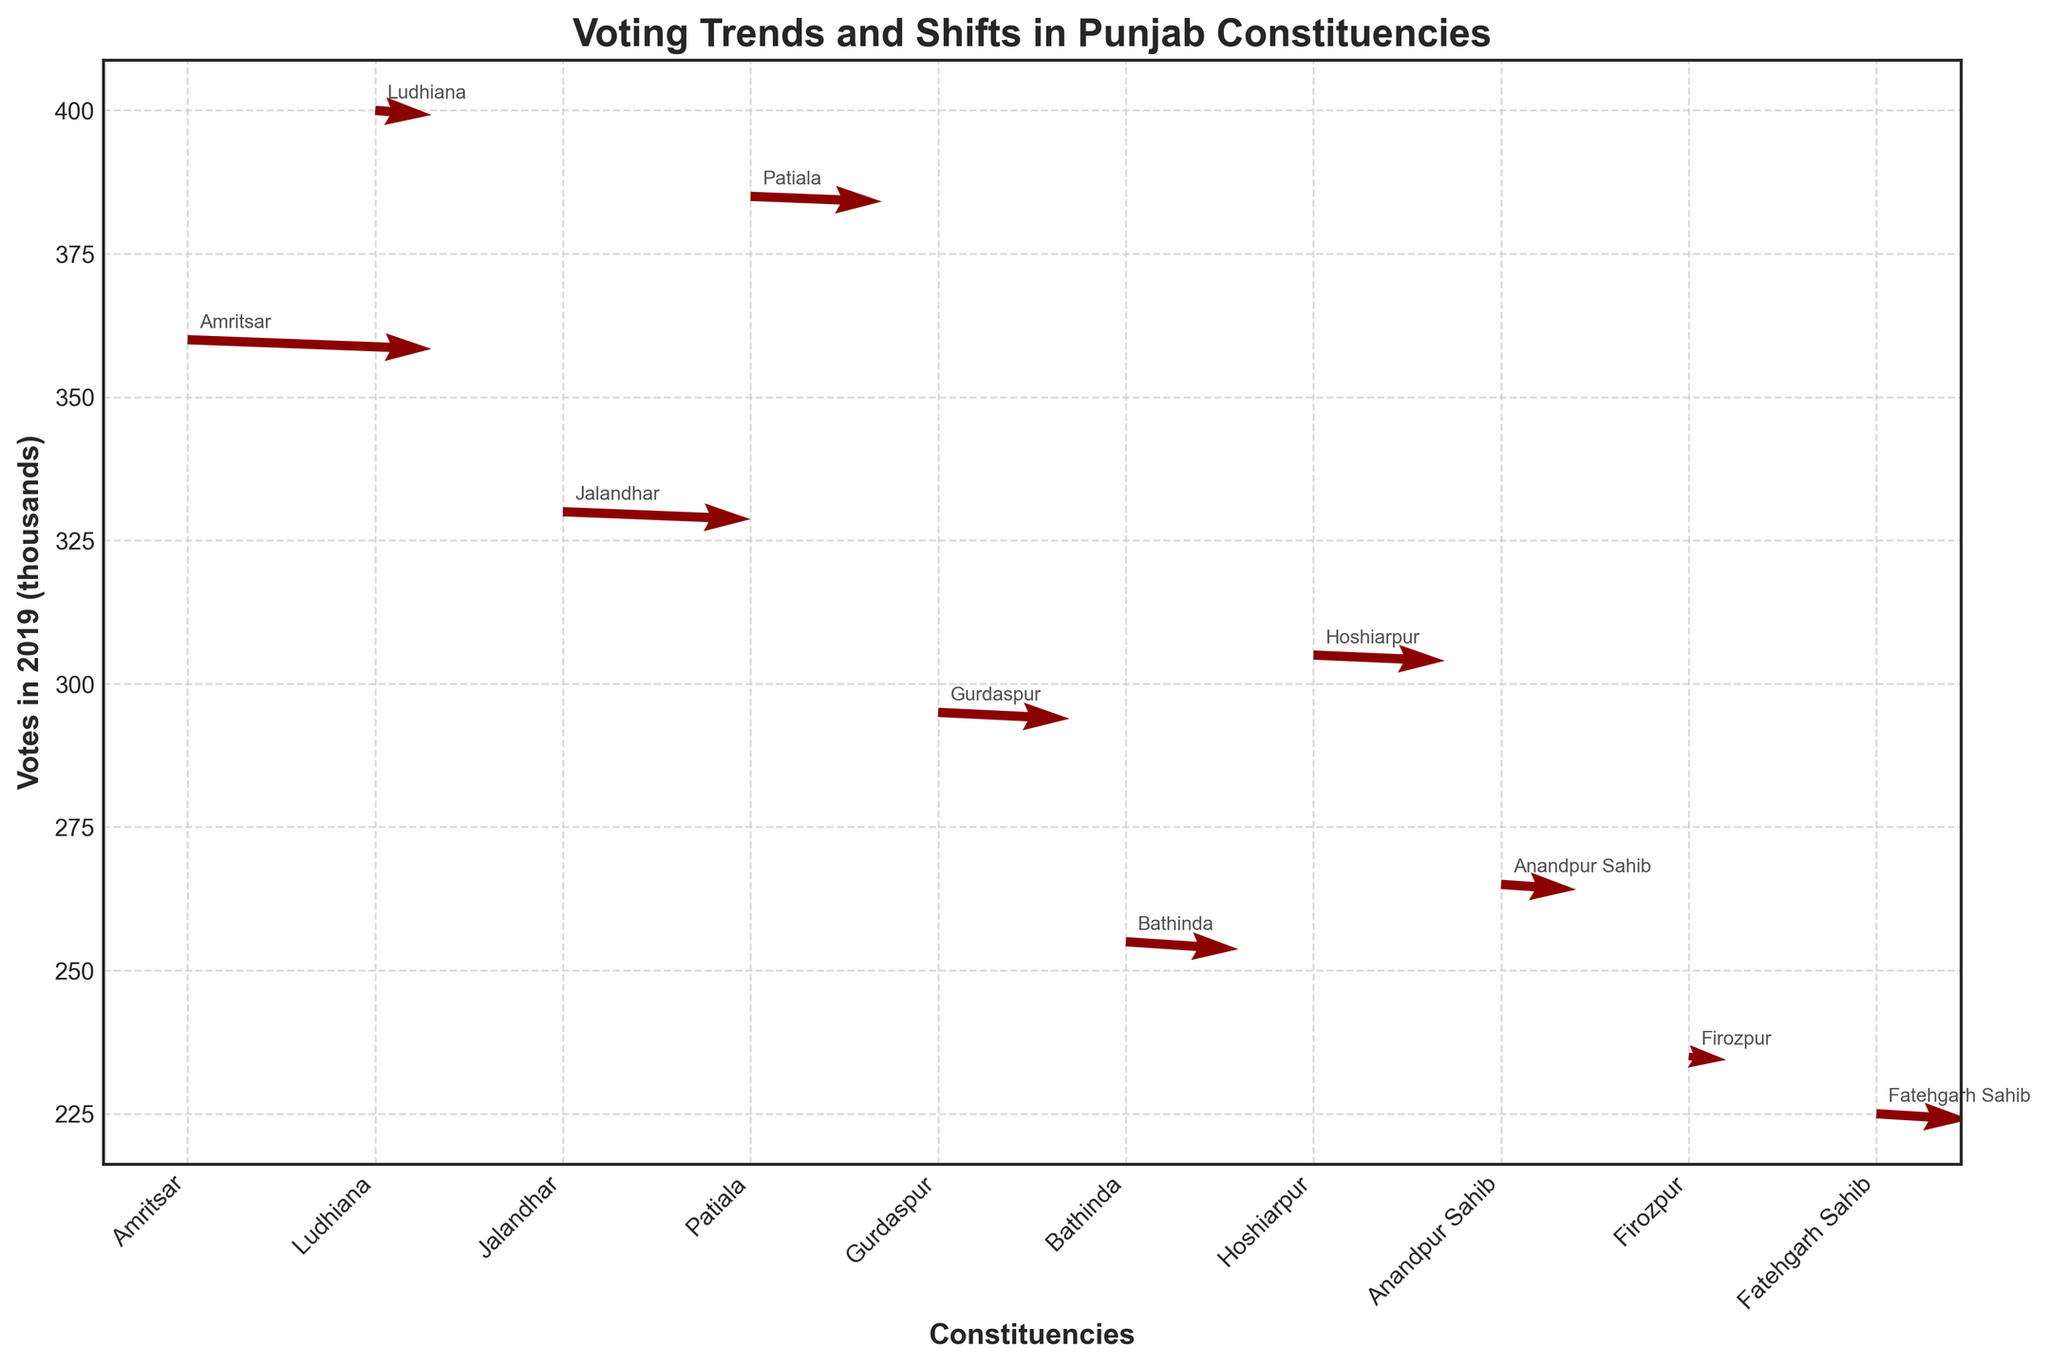What's the title of the plot? The title of the plot is displayed prominently at the top of the figure.
Answer: Voting Trends and Shifts in Punjab Constituencies How many constituencies are represented in the plot? The number of distinct constituency labels on the x-axis represents the number of constituencies. Count these labels to get the answer.
Answer: 10 What is the direction of the voting shift in Amritsar for 2019 compared to 2014? Examine the quiver arrow starting at the point labeled "Amritsar." The U and V components of the vector indicate the direction. For Amritsar, the arrow points generally upward and to the right.
Answer: Upward and to the right Which constituency has the highest number of votes in 2019? Compare the vertical positions of the data points. The highest point on the y-axis corresponds to the constituency with the highest votes in 2019.
Answer: Ludhiana What is the shift in votes for Jalandhar between 2014 and 2019? Locate the arrow corresponding to Jalandhar. The U component (horizontal direction) indicates the vote shift between 2014 and 2019.
Answer: Positive Which constituency showed the largest decrease in votes between 2009 and 2014? Analyze the entire quiver plot. Identify the arrows that point downward and to the left the most, indicating the largest decrease between 2009 and 2014.
Answer: Amritsar What is the average number of votes in 2019 for the constituencies shown? Sum the y-values (votes in thousands) for all constituencies and divide by the number of constituencies: (360+400+330+385+295+255+305+265+235+225)*1000 / 10.
Answer: 305,500 Compare Patiala and Gurdaspur: Which has a higher vote shift in 2019? Examine the U components of the quiver arrows for Patiala and Gurdaspur. The longer arrow in the horizontal direction (U) indicates a higher shift.
Answer: Patiala Which constituency has the least shift magnitude (absolute) in 2019? Identify the arrow with the smallest U component (shift magnitude), irrespective of direction (positive or negative).
Answer: Firozpur 